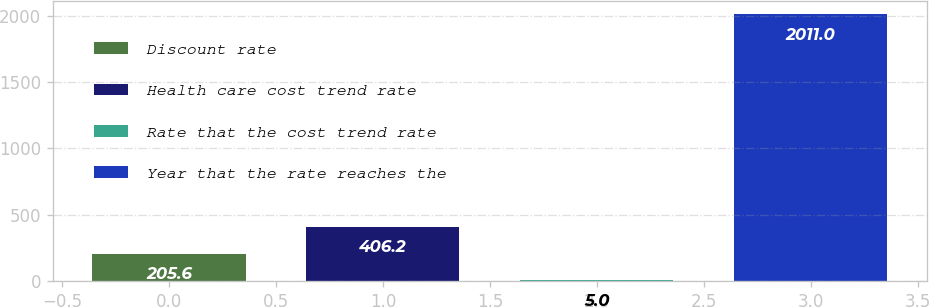Convert chart. <chart><loc_0><loc_0><loc_500><loc_500><bar_chart><fcel>Discount rate<fcel>Health care cost trend rate<fcel>Rate that the cost trend rate<fcel>Year that the rate reaches the<nl><fcel>205.6<fcel>406.2<fcel>5<fcel>2011<nl></chart> 